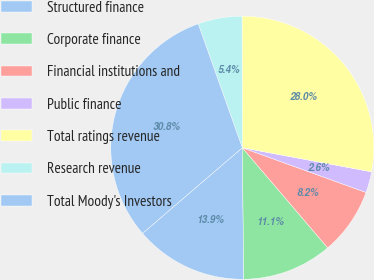Convert chart to OTSL. <chart><loc_0><loc_0><loc_500><loc_500><pie_chart><fcel>Structured finance<fcel>Corporate finance<fcel>Financial institutions and<fcel>Public finance<fcel>Total ratings revenue<fcel>Research revenue<fcel>Total Moody's Investors<nl><fcel>13.89%<fcel>11.06%<fcel>8.24%<fcel>2.59%<fcel>27.97%<fcel>5.41%<fcel>30.85%<nl></chart> 